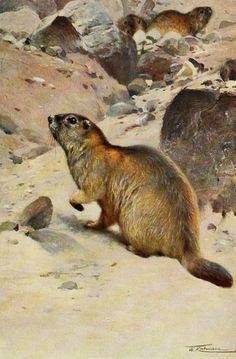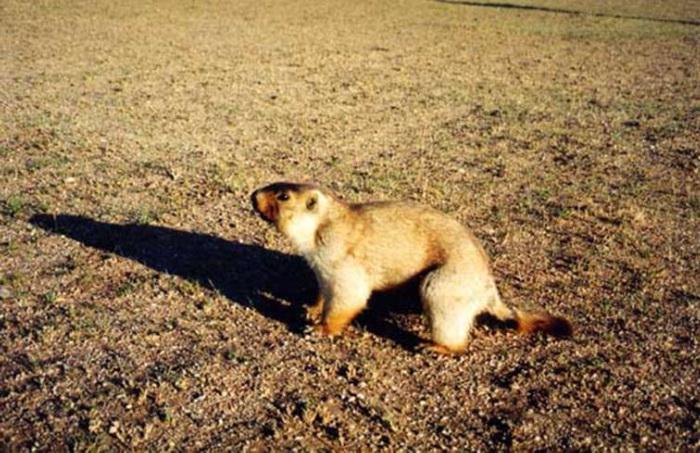The first image is the image on the left, the second image is the image on the right. For the images shown, is this caption "At least one image features a rodent-type animal standing upright." true? Answer yes or no. No. 